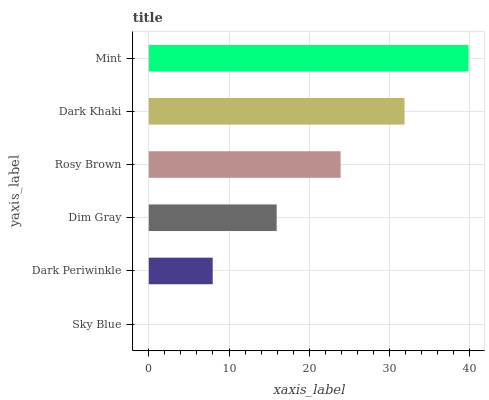Is Sky Blue the minimum?
Answer yes or no. Yes. Is Mint the maximum?
Answer yes or no. Yes. Is Dark Periwinkle the minimum?
Answer yes or no. No. Is Dark Periwinkle the maximum?
Answer yes or no. No. Is Dark Periwinkle greater than Sky Blue?
Answer yes or no. Yes. Is Sky Blue less than Dark Periwinkle?
Answer yes or no. Yes. Is Sky Blue greater than Dark Periwinkle?
Answer yes or no. No. Is Dark Periwinkle less than Sky Blue?
Answer yes or no. No. Is Rosy Brown the high median?
Answer yes or no. Yes. Is Dim Gray the low median?
Answer yes or no. Yes. Is Dim Gray the high median?
Answer yes or no. No. Is Dark Khaki the low median?
Answer yes or no. No. 